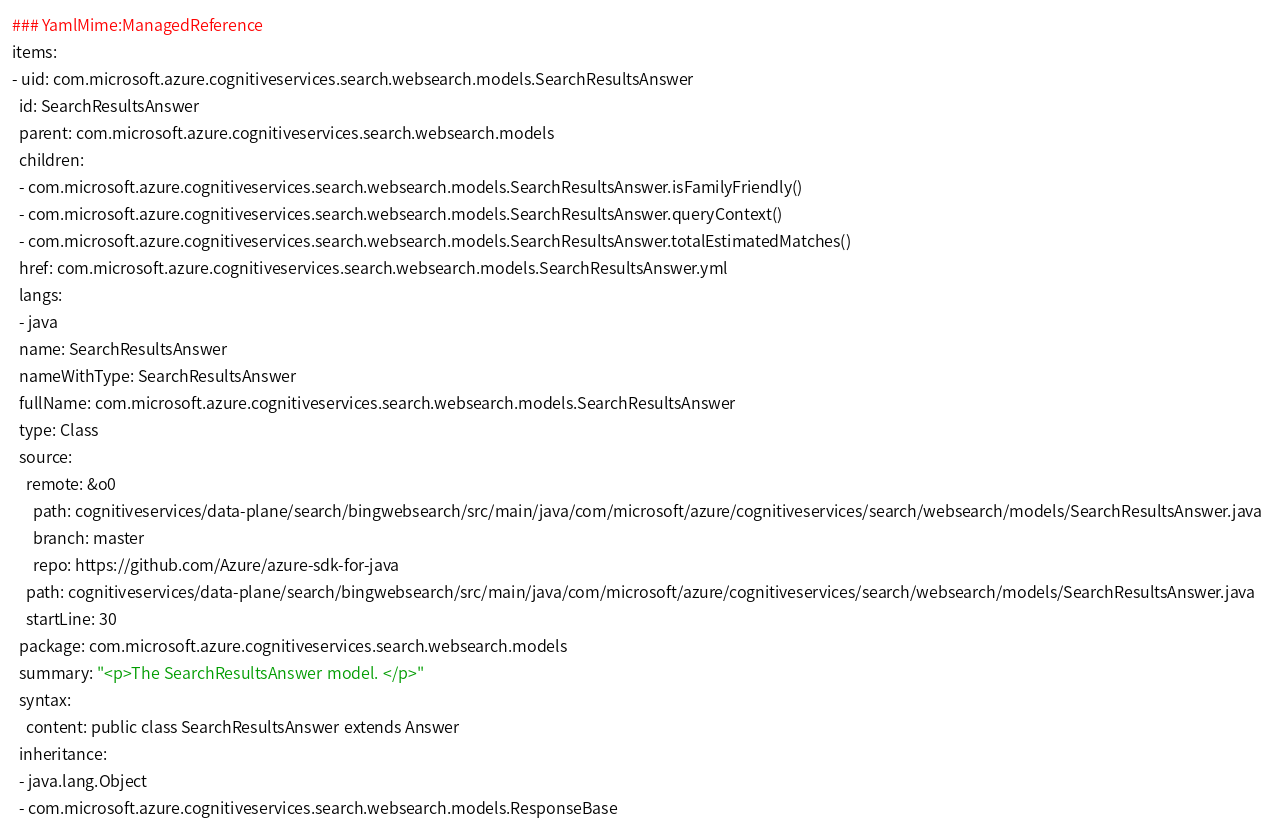Convert code to text. <code><loc_0><loc_0><loc_500><loc_500><_YAML_>### YamlMime:ManagedReference
items:
- uid: com.microsoft.azure.cognitiveservices.search.websearch.models.SearchResultsAnswer
  id: SearchResultsAnswer
  parent: com.microsoft.azure.cognitiveservices.search.websearch.models
  children:
  - com.microsoft.azure.cognitiveservices.search.websearch.models.SearchResultsAnswer.isFamilyFriendly()
  - com.microsoft.azure.cognitiveservices.search.websearch.models.SearchResultsAnswer.queryContext()
  - com.microsoft.azure.cognitiveservices.search.websearch.models.SearchResultsAnswer.totalEstimatedMatches()
  href: com.microsoft.azure.cognitiveservices.search.websearch.models.SearchResultsAnswer.yml
  langs:
  - java
  name: SearchResultsAnswer
  nameWithType: SearchResultsAnswer
  fullName: com.microsoft.azure.cognitiveservices.search.websearch.models.SearchResultsAnswer
  type: Class
  source:
    remote: &o0
      path: cognitiveservices/data-plane/search/bingwebsearch/src/main/java/com/microsoft/azure/cognitiveservices/search/websearch/models/SearchResultsAnswer.java
      branch: master
      repo: https://github.com/Azure/azure-sdk-for-java
    path: cognitiveservices/data-plane/search/bingwebsearch/src/main/java/com/microsoft/azure/cognitiveservices/search/websearch/models/SearchResultsAnswer.java
    startLine: 30
  package: com.microsoft.azure.cognitiveservices.search.websearch.models
  summary: "<p>The SearchResultsAnswer model. </p>"
  syntax:
    content: public class SearchResultsAnswer extends Answer
  inheritance:
  - java.lang.Object
  - com.microsoft.azure.cognitiveservices.search.websearch.models.ResponseBase</code> 